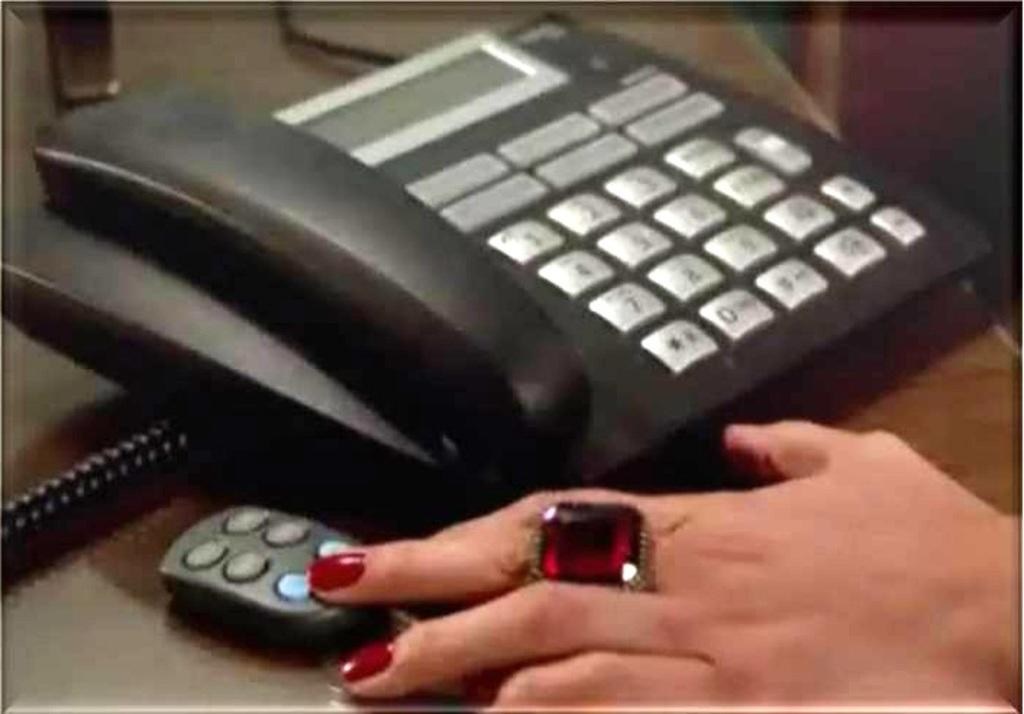What type of telephone is in the image? There is a black color telephone in the image. Where is the telephone located? The telephone is placed on a table. What else can be seen in the image besides the telephone? There is a human hand and a wire on the left side of the image. What is the weight of the orange in the image? There is no orange present in the image, so it is not possible to determine its weight. 